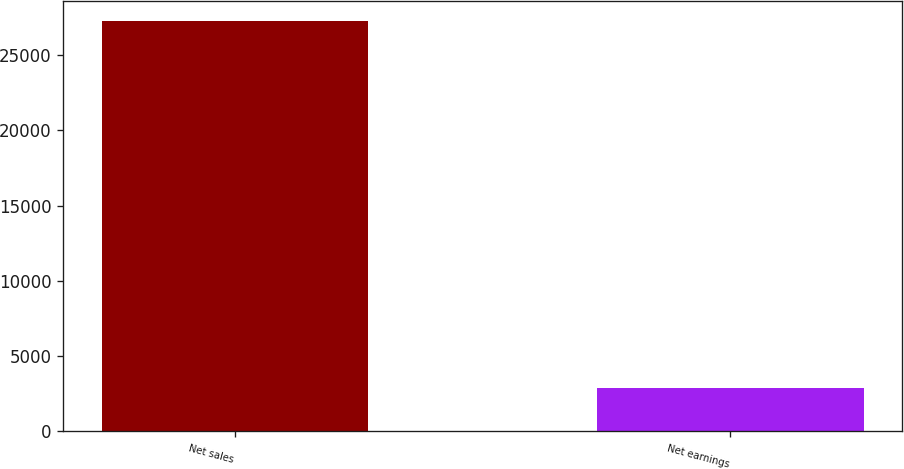Convert chart. <chart><loc_0><loc_0><loc_500><loc_500><bar_chart><fcel>Net sales<fcel>Net earnings<nl><fcel>27254<fcel>2915<nl></chart> 